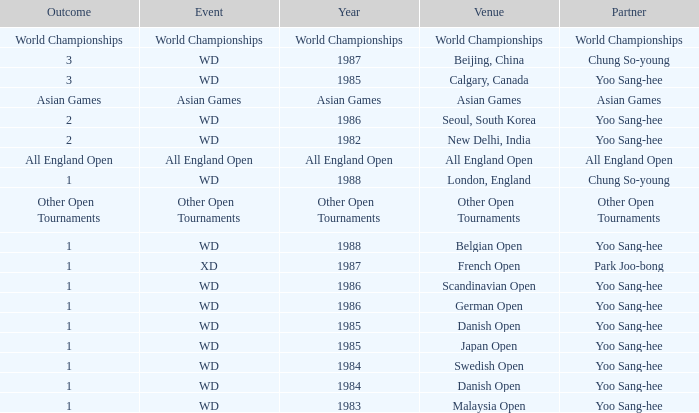What is the final outcome in the malaysia open with collaborator yoo sang-hee? 1.0. 